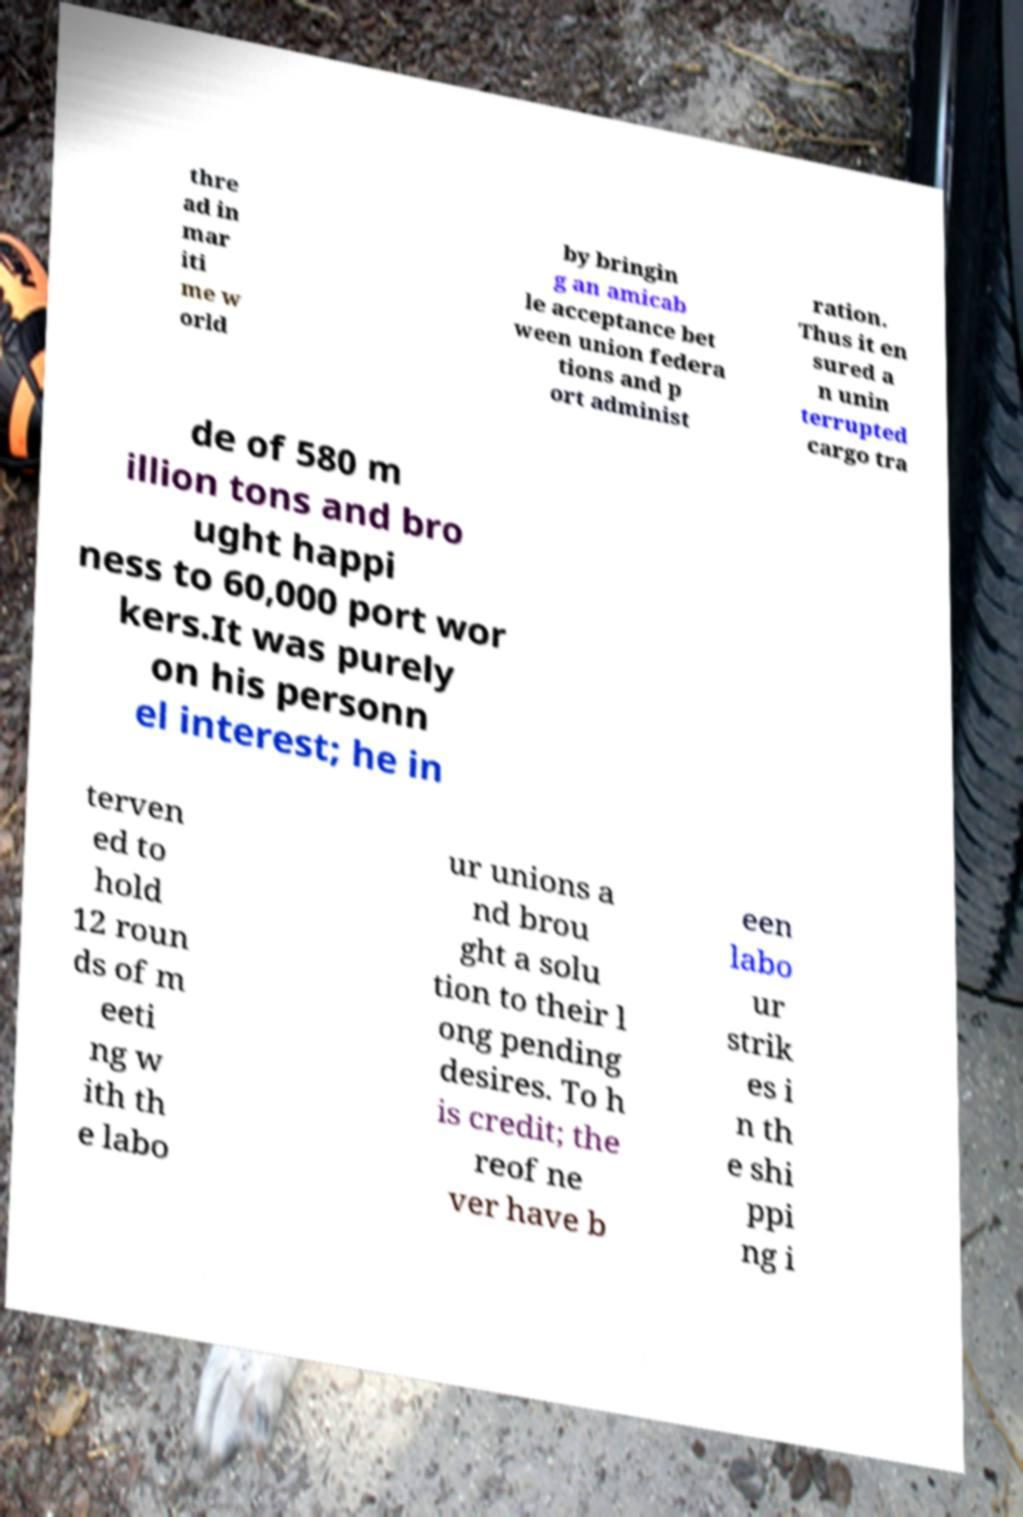Please identify and transcribe the text found in this image. thre ad in mar iti me w orld by bringin g an amicab le acceptance bet ween union federa tions and p ort administ ration. Thus it en sured a n unin terrupted cargo tra de of 580 m illion tons and bro ught happi ness to 60,000 port wor kers.It was purely on his personn el interest; he in terven ed to hold 12 roun ds of m eeti ng w ith th e labo ur unions a nd brou ght a solu tion to their l ong pending desires. To h is credit; the reof ne ver have b een labo ur strik es i n th e shi ppi ng i 